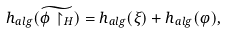<formula> <loc_0><loc_0><loc_500><loc_500>h _ { a l g } ( \widetilde { \phi \upharpoonright _ { H } } ) = h _ { a l g } ( \xi ) + h _ { a l g } ( \varphi ) ,</formula> 